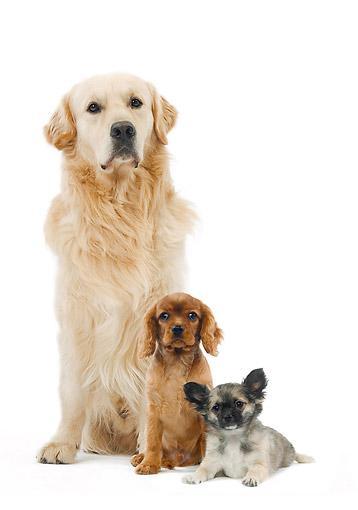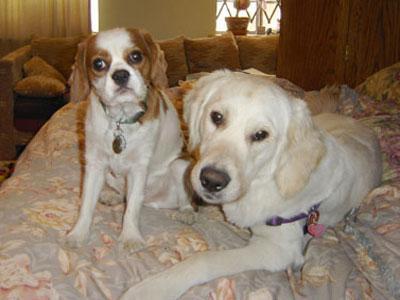The first image is the image on the left, the second image is the image on the right. Evaluate the accuracy of this statement regarding the images: "There are only three dogs.". Is it true? Answer yes or no. No. The first image is the image on the left, the second image is the image on the right. For the images shown, is this caption "There ar no more than 3 dogs in the image pair" true? Answer yes or no. No. 